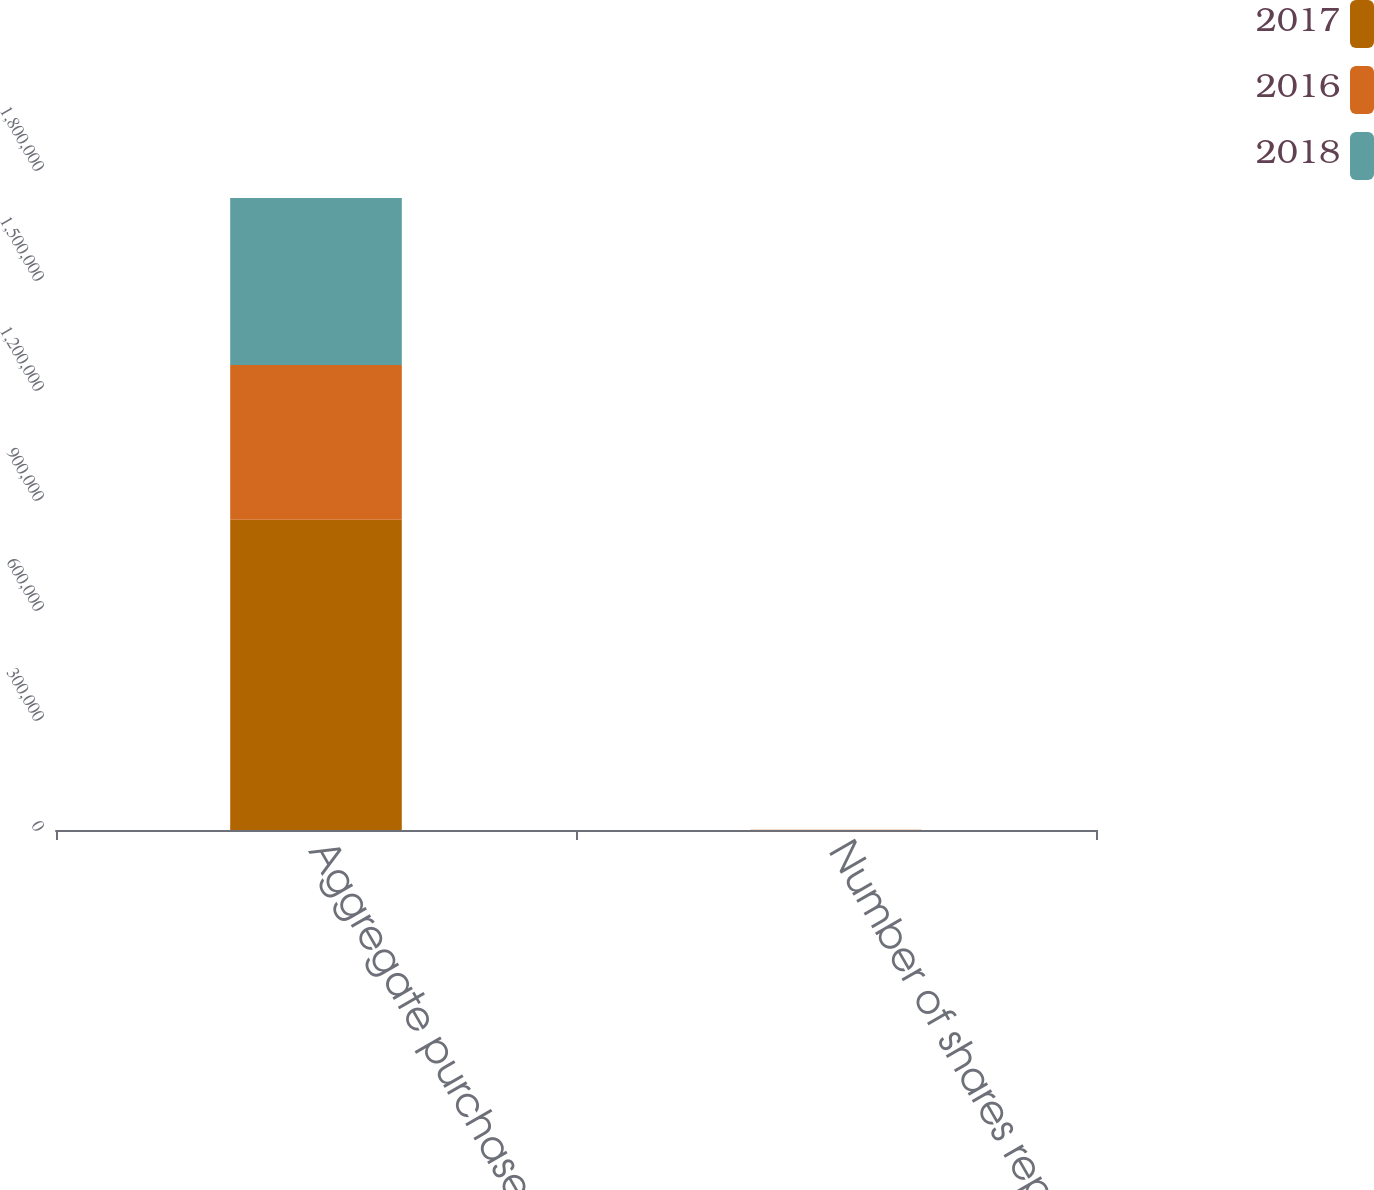<chart> <loc_0><loc_0><loc_500><loc_500><stacked_bar_chart><ecel><fcel>Aggregate purchase price<fcel>Number of shares repurchased<nl><fcel>2017<fcel>846134<fcel>301<nl><fcel>2016<fcel>422166<fcel>167<nl><fcel>2018<fcel>455351<fcel>280<nl></chart> 